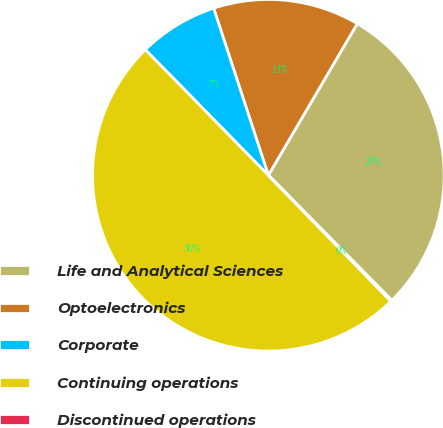Convert chart to OTSL. <chart><loc_0><loc_0><loc_500><loc_500><pie_chart><fcel>Life and Analytical Sciences<fcel>Optoelectronics<fcel>Corporate<fcel>Continuing operations<fcel>Discontinued operations<nl><fcel>29.17%<fcel>13.48%<fcel>7.3%<fcel>49.94%<fcel>0.12%<nl></chart> 